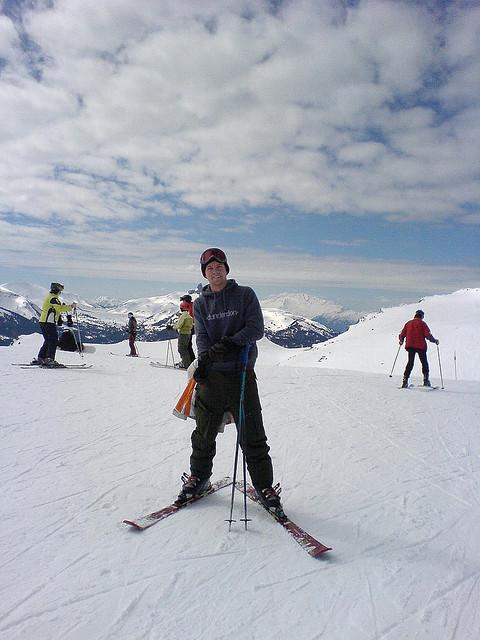What color is the jacket of the skier on the right?
Write a very short answer. Red. Has the skier folded his arms?
Write a very short answer. Yes. Has the slope been recently groomed?
Quick response, please. Yes. Are all of the children wearing helmets?
Short answer required. No. How many skiers are there?
Answer briefly. 5. Is this person going downhill?
Answer briefly. No. 